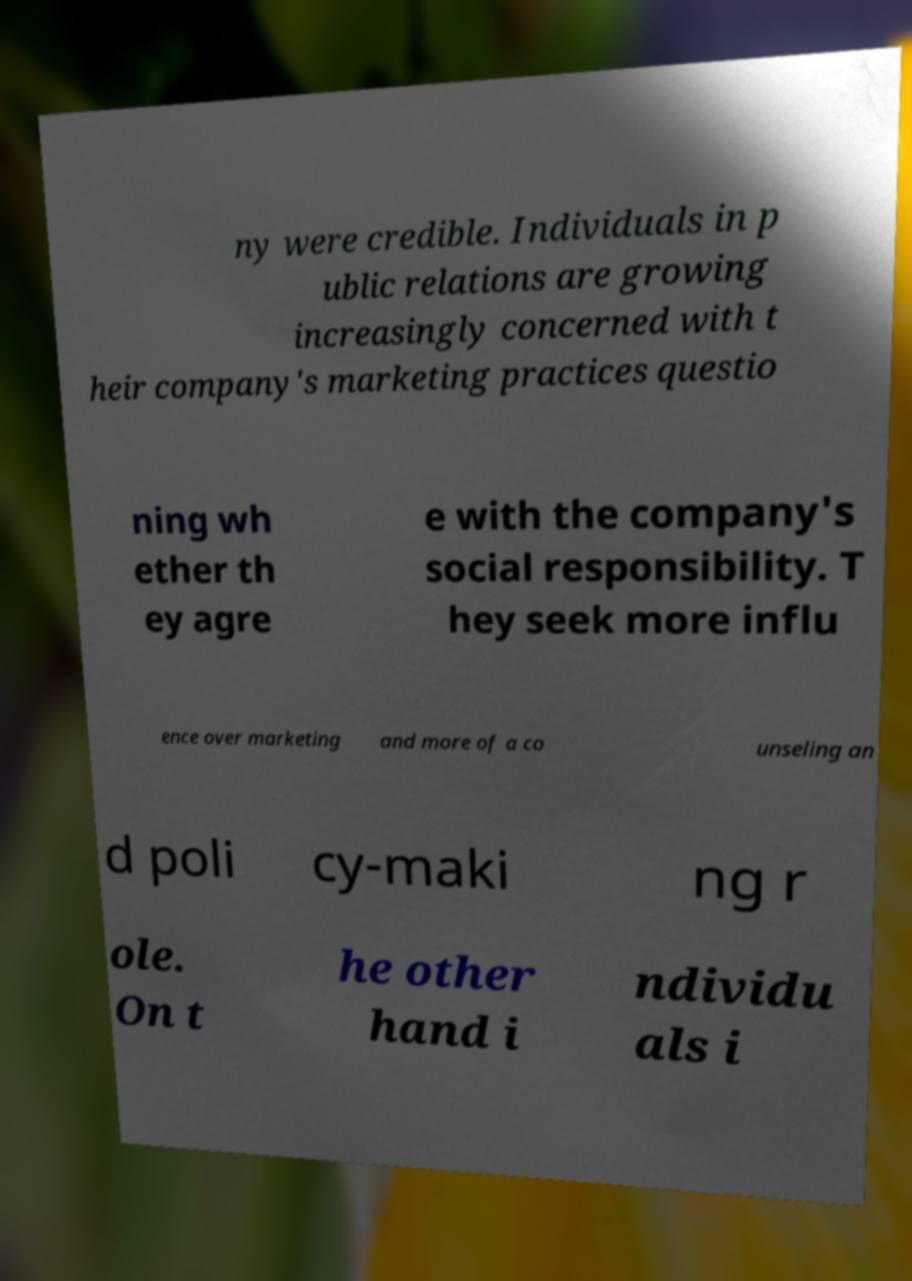There's text embedded in this image that I need extracted. Can you transcribe it verbatim? ny were credible. Individuals in p ublic relations are growing increasingly concerned with t heir company's marketing practices questio ning wh ether th ey agre e with the company's social responsibility. T hey seek more influ ence over marketing and more of a co unseling an d poli cy-maki ng r ole. On t he other hand i ndividu als i 